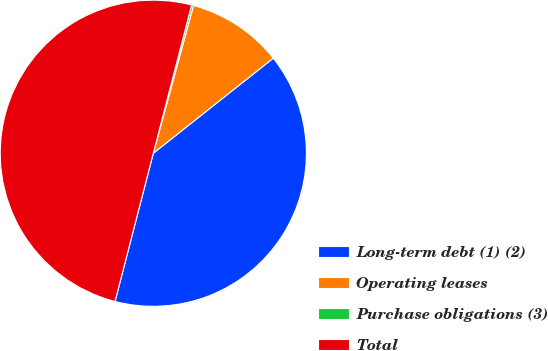Convert chart. <chart><loc_0><loc_0><loc_500><loc_500><pie_chart><fcel>Long-term debt (1) (2)<fcel>Operating leases<fcel>Purchase obligations (3)<fcel>Total<nl><fcel>39.69%<fcel>10.1%<fcel>0.21%<fcel>50.0%<nl></chart> 